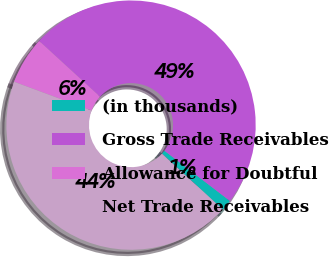Convert chart to OTSL. <chart><loc_0><loc_0><loc_500><loc_500><pie_chart><fcel>(in thousands)<fcel>Gross Trade Receivables<fcel>Allowance for Doubtful<fcel>Net Trade Receivables<nl><fcel>1.43%<fcel>48.61%<fcel>6.15%<fcel>43.82%<nl></chart> 